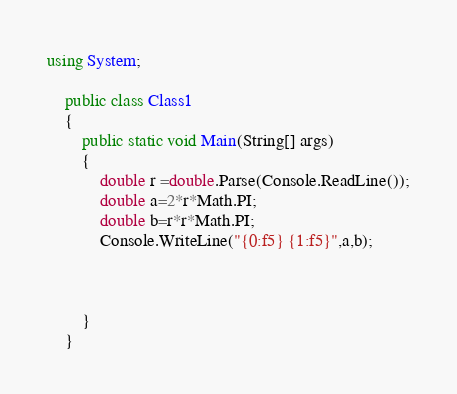<code> <loc_0><loc_0><loc_500><loc_500><_C#_>using System;

	public class Class1
	{
		public static void Main(String[] args)
		{
			double r =double.Parse(Console.ReadLine());
			double a=2*r*Math.PI;
			double b=r*r*Math.PI;
			Console.WriteLine("{0:f5} {1:f5}",a,b);
			
			
			
		}
	}</code> 